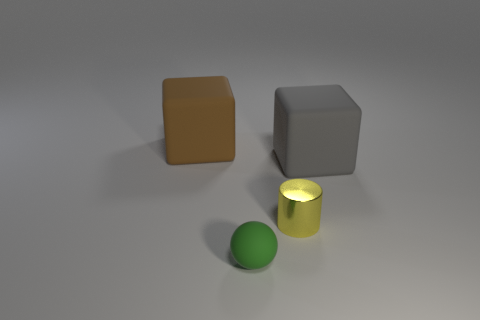Add 2 cubes. How many objects exist? 6 Subtract all gray blocks. How many blocks are left? 1 Add 2 yellow metallic cylinders. How many yellow metallic cylinders exist? 3 Subtract 0 blue cylinders. How many objects are left? 4 Subtract all spheres. How many objects are left? 3 Subtract 1 cubes. How many cubes are left? 1 Subtract all green blocks. Subtract all green cylinders. How many blocks are left? 2 Subtract all red balls. How many brown cubes are left? 1 Subtract all tiny green shiny spheres. Subtract all tiny things. How many objects are left? 2 Add 4 big gray things. How many big gray things are left? 5 